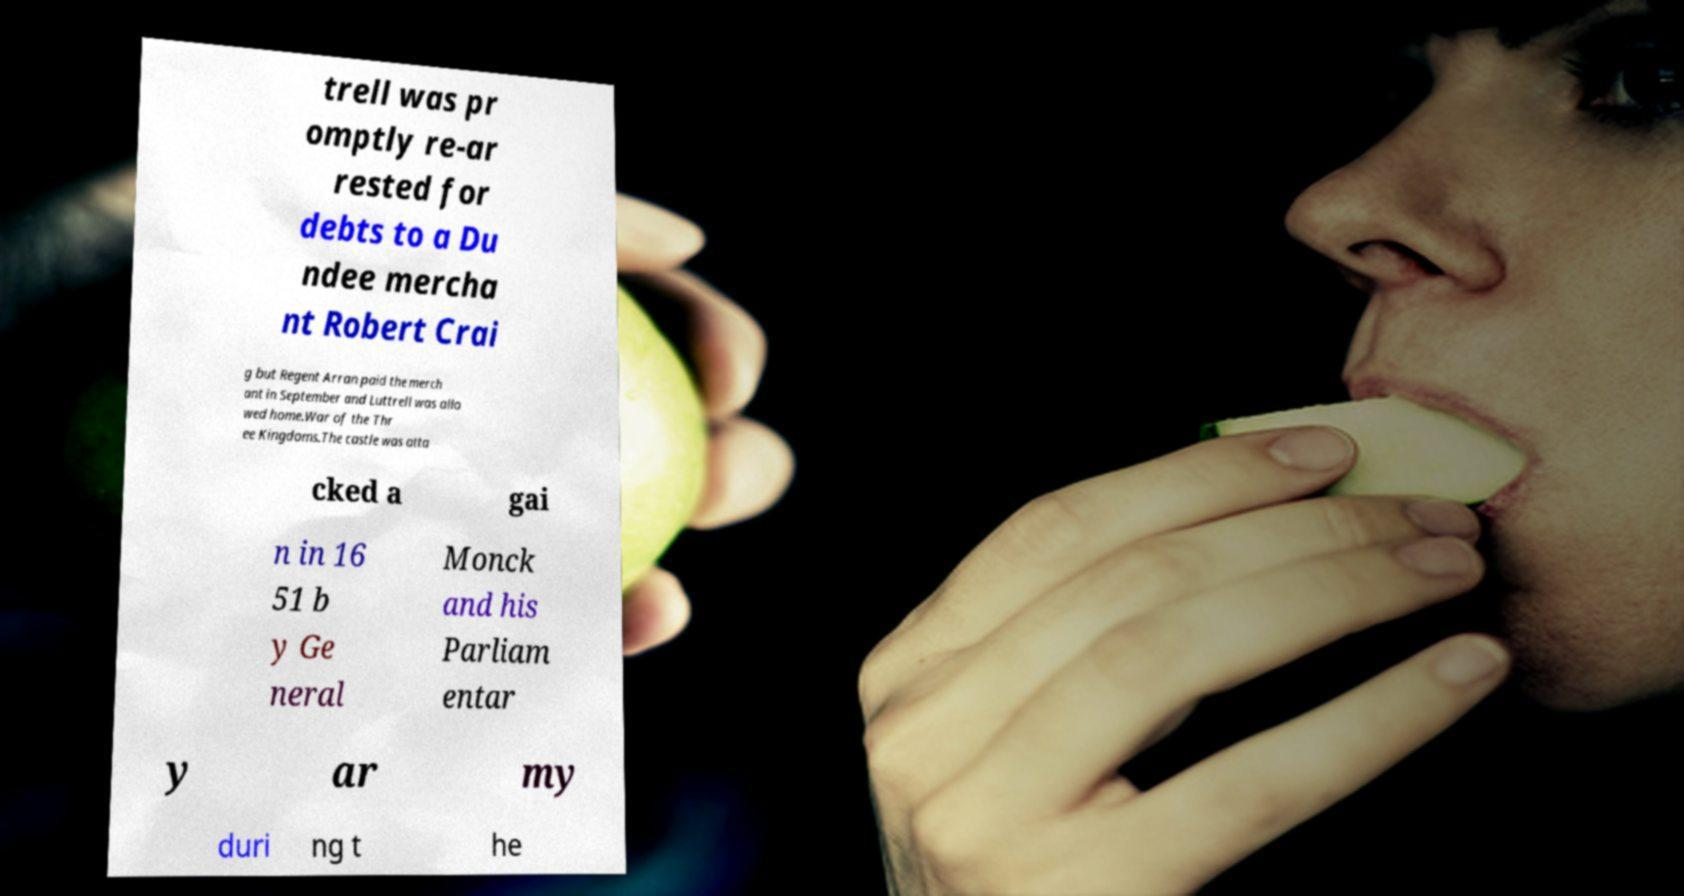Could you assist in decoding the text presented in this image and type it out clearly? trell was pr omptly re-ar rested for debts to a Du ndee mercha nt Robert Crai g but Regent Arran paid the merch ant in September and Luttrell was allo wed home.War of the Thr ee Kingdoms.The castle was atta cked a gai n in 16 51 b y Ge neral Monck and his Parliam entar y ar my duri ng t he 